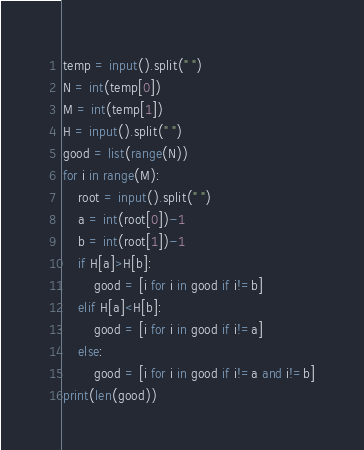Convert code to text. <code><loc_0><loc_0><loc_500><loc_500><_Python_>temp = input().split(" ")
N = int(temp[0])
M = int(temp[1])
H = input().split(" ")
good = list(range(N))
for i in range(M):
    root = input().split(" ")
    a = int(root[0])-1
    b = int(root[1])-1
    if H[a]>H[b]:
        good = [i for i in good if i!=b]
    elif H[a]<H[b]:
        good = [i for i in good if i!=a]
    else:
        good = [i for i in good if i!=a and i!=b]
print(len(good))</code> 